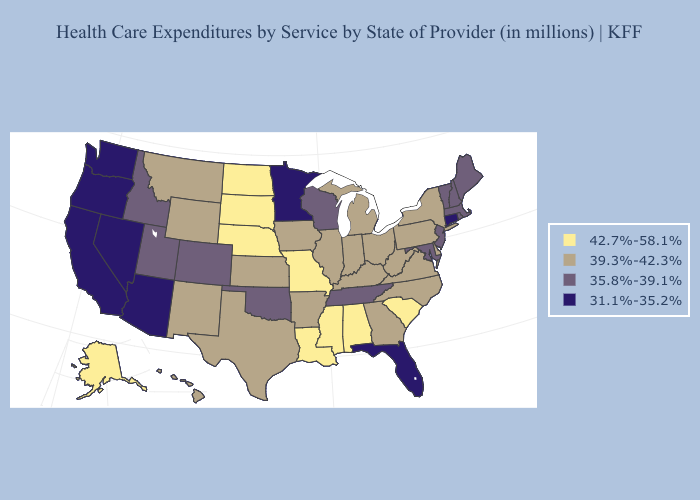What is the value of Maryland?
Keep it brief. 35.8%-39.1%. Among the states that border South Dakota , does Minnesota have the highest value?
Be succinct. No. Does Connecticut have the lowest value in the Northeast?
Short answer required. Yes. Which states have the lowest value in the USA?
Quick response, please. Arizona, California, Connecticut, Florida, Minnesota, Nevada, Oregon, Washington. Name the states that have a value in the range 31.1%-35.2%?
Give a very brief answer. Arizona, California, Connecticut, Florida, Minnesota, Nevada, Oregon, Washington. What is the value of Texas?
Be succinct. 39.3%-42.3%. Does Arkansas have a higher value than Hawaii?
Quick response, please. No. What is the value of North Dakota?
Quick response, please. 42.7%-58.1%. Among the states that border Rhode Island , does Massachusetts have the lowest value?
Short answer required. No. Which states have the highest value in the USA?
Be succinct. Alabama, Alaska, Louisiana, Mississippi, Missouri, Nebraska, North Dakota, South Carolina, South Dakota. What is the value of Kansas?
Be succinct. 39.3%-42.3%. Name the states that have a value in the range 31.1%-35.2%?
Short answer required. Arizona, California, Connecticut, Florida, Minnesota, Nevada, Oregon, Washington. Name the states that have a value in the range 31.1%-35.2%?
Be succinct. Arizona, California, Connecticut, Florida, Minnesota, Nevada, Oregon, Washington. What is the value of New Jersey?
Write a very short answer. 35.8%-39.1%. What is the lowest value in the USA?
Give a very brief answer. 31.1%-35.2%. 